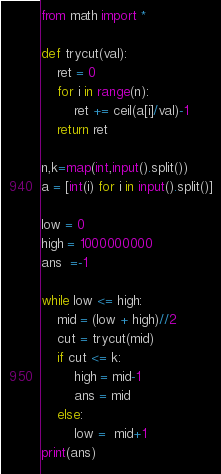Convert code to text. <code><loc_0><loc_0><loc_500><loc_500><_Python_>from math import *

def trycut(val):
	ret = 0
	for i in range(n):
		ret += ceil(a[i]/val)-1
	return ret 

n,k=map(int,input().split())
a = [int(i) for i in input().split()]

low = 0
high = 1000000000
ans  =-1

while low <= high:
	mid = (low + high)//2
	cut = trycut(mid)
	if cut <= k:
		high = mid-1
		ans = mid
	else:
		low =  mid+1
print(ans)


</code> 